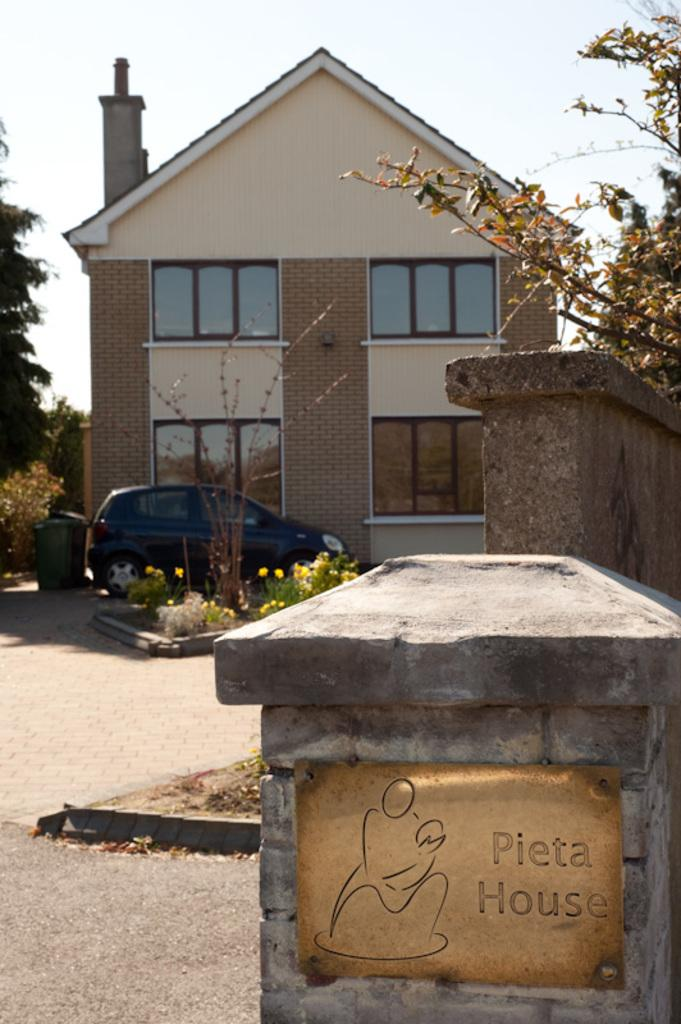What type of structure is present in the image? There is a building in the image. What mode of transportation can be seen near the building? There is a black color car in the image. What is visible at the top of the image? The sky is visible at the top of the image. What features can be seen on the building? There are windows in the building. What type of vegetation is present in the image? There are plants, flowers, and trees in the image. How many snakes are slithering around the car in the image? There are no snakes present in the image. What type of stem is holding up the flowers in the image? The flowers are not shown with stems in the image. 